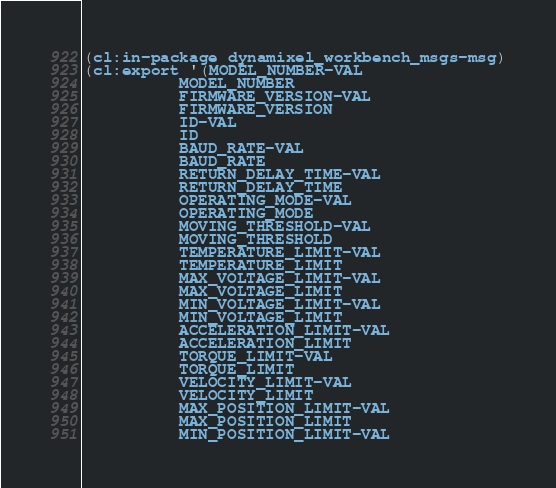<code> <loc_0><loc_0><loc_500><loc_500><_Lisp_>(cl:in-package dynamixel_workbench_msgs-msg)
(cl:export '(MODEL_NUMBER-VAL
          MODEL_NUMBER
          FIRMWARE_VERSION-VAL
          FIRMWARE_VERSION
          ID-VAL
          ID
          BAUD_RATE-VAL
          BAUD_RATE
          RETURN_DELAY_TIME-VAL
          RETURN_DELAY_TIME
          OPERATING_MODE-VAL
          OPERATING_MODE
          MOVING_THRESHOLD-VAL
          MOVING_THRESHOLD
          TEMPERATURE_LIMIT-VAL
          TEMPERATURE_LIMIT
          MAX_VOLTAGE_LIMIT-VAL
          MAX_VOLTAGE_LIMIT
          MIN_VOLTAGE_LIMIT-VAL
          MIN_VOLTAGE_LIMIT
          ACCELERATION_LIMIT-VAL
          ACCELERATION_LIMIT
          TORQUE_LIMIT-VAL
          TORQUE_LIMIT
          VELOCITY_LIMIT-VAL
          VELOCITY_LIMIT
          MAX_POSITION_LIMIT-VAL
          MAX_POSITION_LIMIT
          MIN_POSITION_LIMIT-VAL</code> 